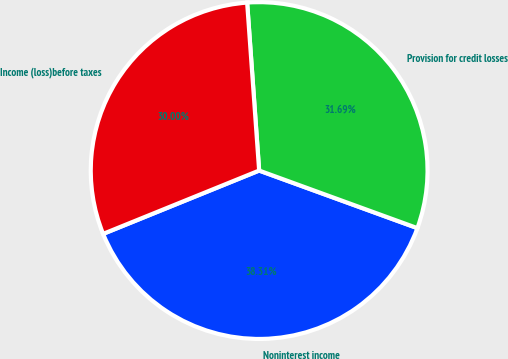Convert chart to OTSL. <chart><loc_0><loc_0><loc_500><loc_500><pie_chart><fcel>Noninterest income<fcel>Provision for credit losses<fcel>Income (loss)before taxes<nl><fcel>38.31%<fcel>31.69%<fcel>30.0%<nl></chart> 